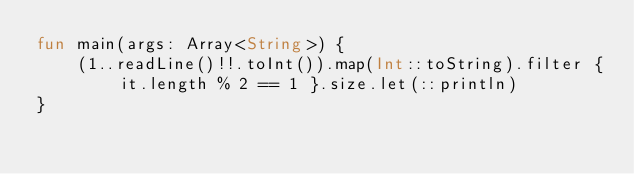<code> <loc_0><loc_0><loc_500><loc_500><_Kotlin_>fun main(args: Array<String>) {
    (1..readLine()!!.toInt()).map(Int::toString).filter { it.length % 2 == 1 }.size.let(::println)
}
</code> 